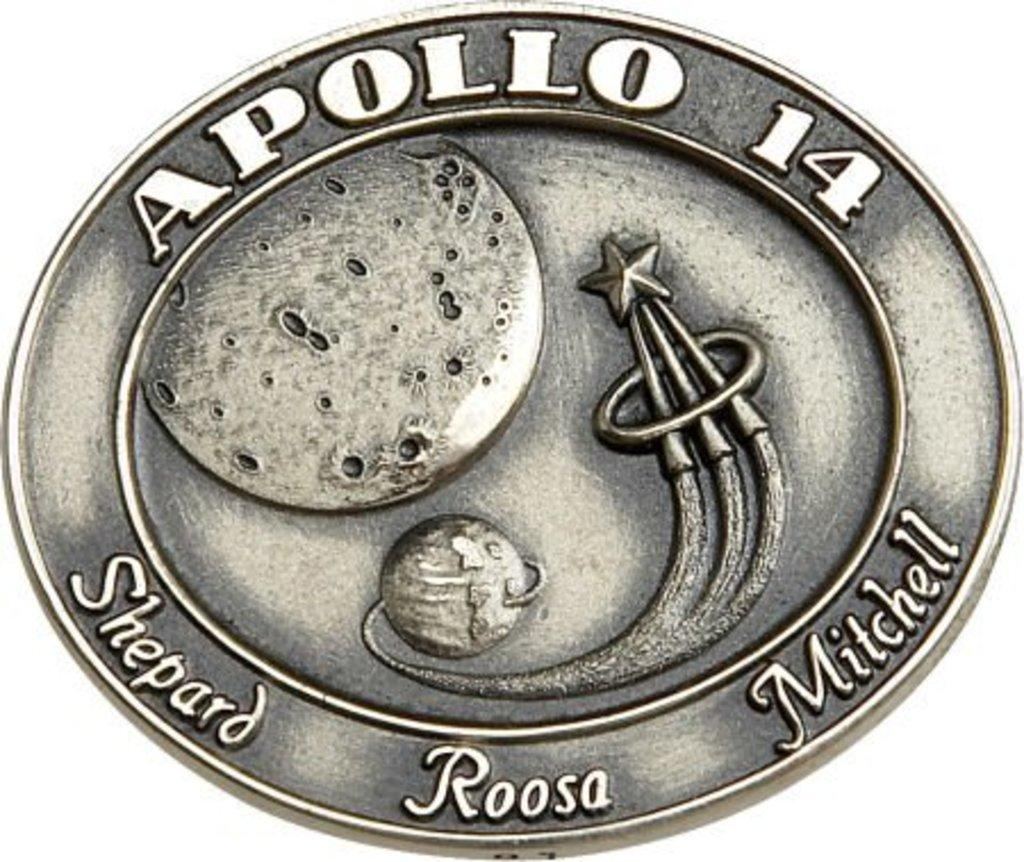What is the main subject in the center of the image? There is a poster in the center of the image. What can be read on the poster? The poster has the word "apollo" written on it. How many experts are shown working on the transport project in the image? There are no experts or transport projects depicted in the image; it only features a poster with the word "apollo" written on it. What type of finger can be seen pointing at the word "apollo" in the image? There are no fingers or any indication of pointing in the image; it only features a poster with the word "apollo" written on it. 